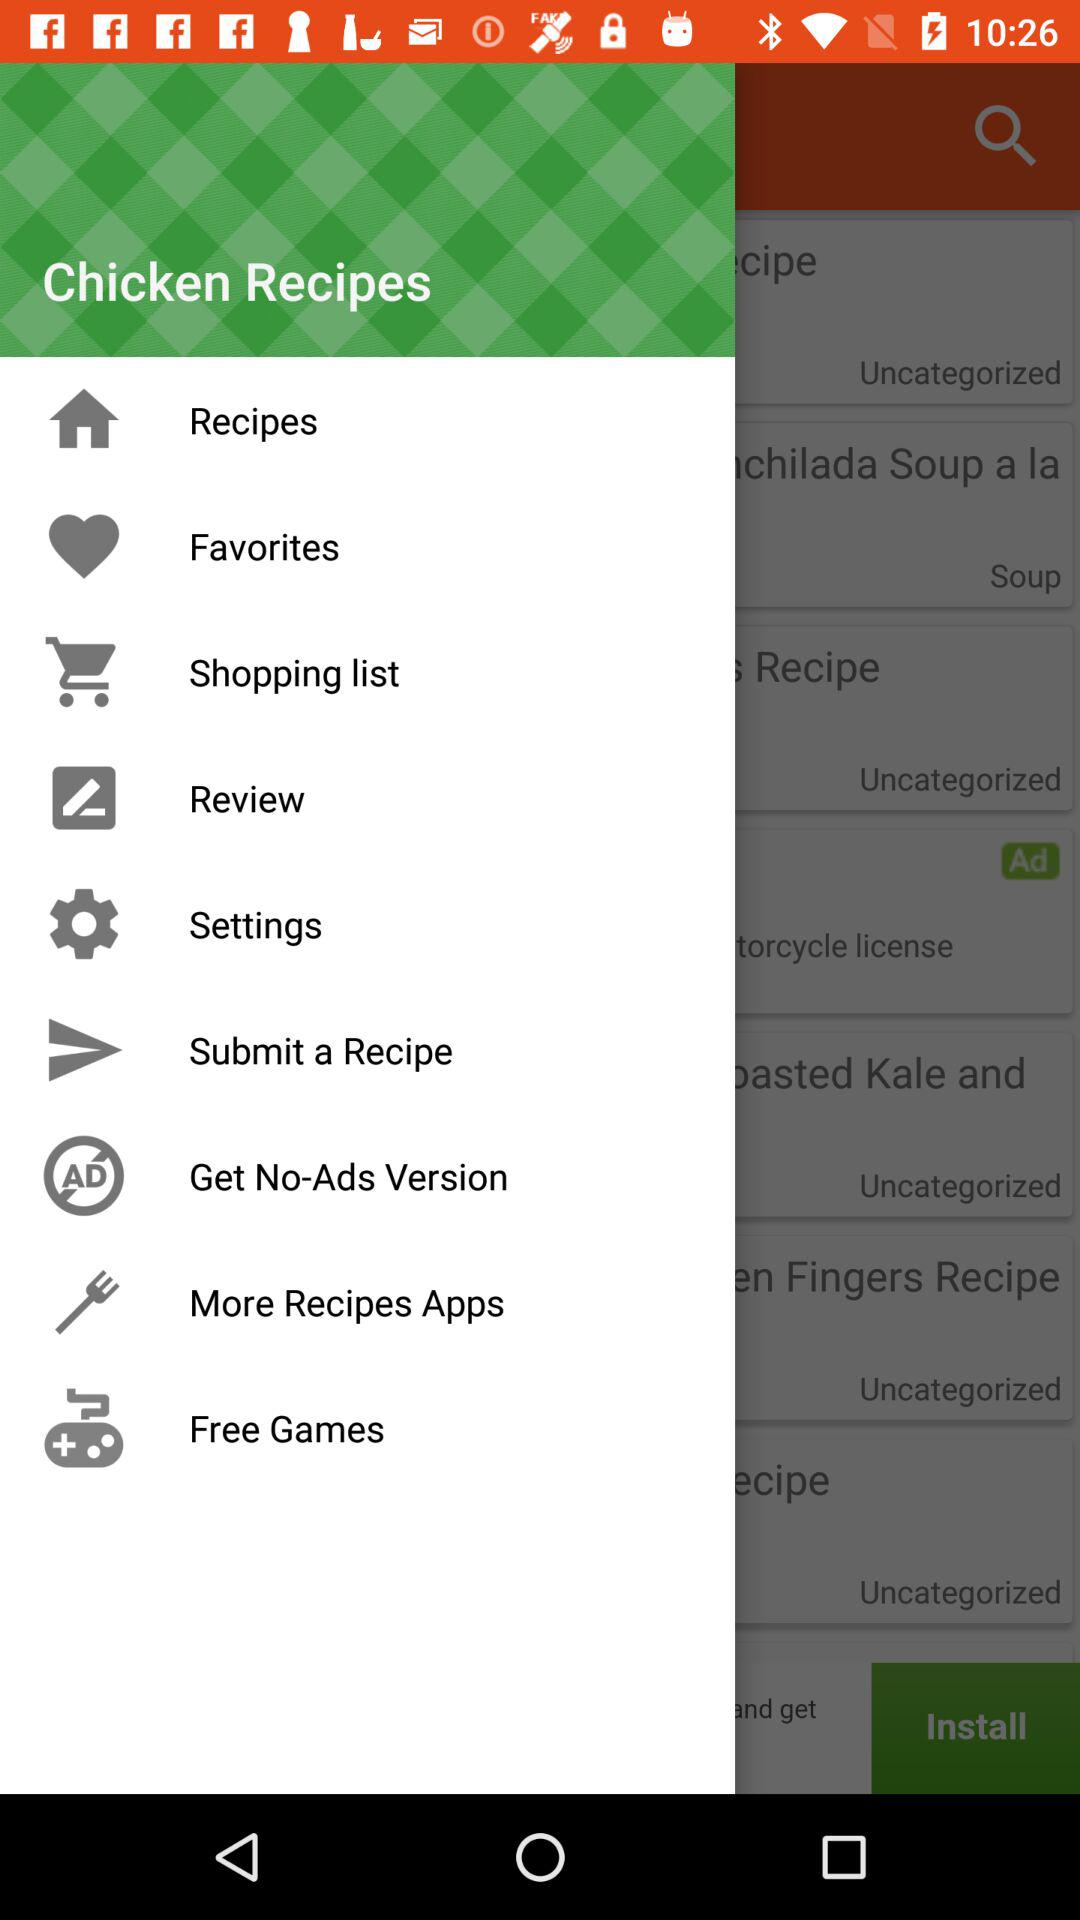What is the application name? The application name is "Chicken Recipes". 